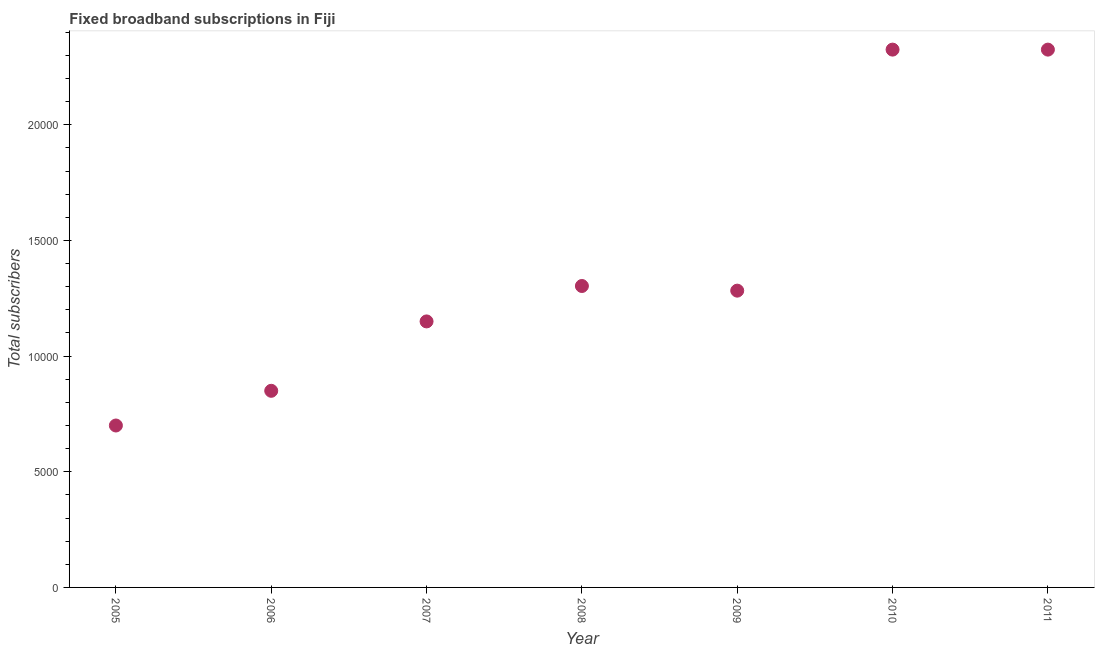What is the total number of fixed broadband subscriptions in 2009?
Provide a succinct answer. 1.28e+04. Across all years, what is the maximum total number of fixed broadband subscriptions?
Your answer should be compact. 2.32e+04. Across all years, what is the minimum total number of fixed broadband subscriptions?
Keep it short and to the point. 7000. What is the sum of the total number of fixed broadband subscriptions?
Your response must be concise. 9.94e+04. What is the difference between the total number of fixed broadband subscriptions in 2006 and 2010?
Provide a short and direct response. -1.48e+04. What is the average total number of fixed broadband subscriptions per year?
Your answer should be very brief. 1.42e+04. What is the median total number of fixed broadband subscriptions?
Offer a terse response. 1.28e+04. In how many years, is the total number of fixed broadband subscriptions greater than 6000 ?
Offer a terse response. 7. What is the ratio of the total number of fixed broadband subscriptions in 2006 to that in 2009?
Your answer should be compact. 0.66. Is the total number of fixed broadband subscriptions in 2007 less than that in 2010?
Give a very brief answer. Yes. Is the difference between the total number of fixed broadband subscriptions in 2009 and 2010 greater than the difference between any two years?
Your response must be concise. No. Is the sum of the total number of fixed broadband subscriptions in 2005 and 2006 greater than the maximum total number of fixed broadband subscriptions across all years?
Offer a very short reply. No. What is the difference between the highest and the lowest total number of fixed broadband subscriptions?
Ensure brevity in your answer.  1.62e+04. Does the total number of fixed broadband subscriptions monotonically increase over the years?
Provide a succinct answer. No. How many dotlines are there?
Ensure brevity in your answer.  1. How many years are there in the graph?
Your answer should be compact. 7. What is the difference between two consecutive major ticks on the Y-axis?
Your answer should be very brief. 5000. Are the values on the major ticks of Y-axis written in scientific E-notation?
Make the answer very short. No. Does the graph contain any zero values?
Ensure brevity in your answer.  No. Does the graph contain grids?
Offer a terse response. No. What is the title of the graph?
Give a very brief answer. Fixed broadband subscriptions in Fiji. What is the label or title of the X-axis?
Your answer should be very brief. Year. What is the label or title of the Y-axis?
Make the answer very short. Total subscribers. What is the Total subscribers in 2005?
Give a very brief answer. 7000. What is the Total subscribers in 2006?
Your answer should be compact. 8500. What is the Total subscribers in 2007?
Make the answer very short. 1.15e+04. What is the Total subscribers in 2008?
Provide a short and direct response. 1.30e+04. What is the Total subscribers in 2009?
Make the answer very short. 1.28e+04. What is the Total subscribers in 2010?
Your response must be concise. 2.32e+04. What is the Total subscribers in 2011?
Offer a terse response. 2.32e+04. What is the difference between the Total subscribers in 2005 and 2006?
Your answer should be compact. -1500. What is the difference between the Total subscribers in 2005 and 2007?
Make the answer very short. -4500. What is the difference between the Total subscribers in 2005 and 2008?
Give a very brief answer. -6031. What is the difference between the Total subscribers in 2005 and 2009?
Give a very brief answer. -5830. What is the difference between the Total subscribers in 2005 and 2010?
Give a very brief answer. -1.62e+04. What is the difference between the Total subscribers in 2005 and 2011?
Your response must be concise. -1.62e+04. What is the difference between the Total subscribers in 2006 and 2007?
Offer a terse response. -3000. What is the difference between the Total subscribers in 2006 and 2008?
Provide a short and direct response. -4531. What is the difference between the Total subscribers in 2006 and 2009?
Give a very brief answer. -4330. What is the difference between the Total subscribers in 2006 and 2010?
Make the answer very short. -1.48e+04. What is the difference between the Total subscribers in 2006 and 2011?
Give a very brief answer. -1.48e+04. What is the difference between the Total subscribers in 2007 and 2008?
Offer a very short reply. -1531. What is the difference between the Total subscribers in 2007 and 2009?
Keep it short and to the point. -1330. What is the difference between the Total subscribers in 2007 and 2010?
Your answer should be compact. -1.18e+04. What is the difference between the Total subscribers in 2007 and 2011?
Make the answer very short. -1.18e+04. What is the difference between the Total subscribers in 2008 and 2009?
Provide a short and direct response. 201. What is the difference between the Total subscribers in 2008 and 2010?
Your answer should be compact. -1.02e+04. What is the difference between the Total subscribers in 2008 and 2011?
Your answer should be compact. -1.02e+04. What is the difference between the Total subscribers in 2009 and 2010?
Offer a terse response. -1.04e+04. What is the difference between the Total subscribers in 2009 and 2011?
Your answer should be compact. -1.04e+04. What is the ratio of the Total subscribers in 2005 to that in 2006?
Offer a terse response. 0.82. What is the ratio of the Total subscribers in 2005 to that in 2007?
Ensure brevity in your answer.  0.61. What is the ratio of the Total subscribers in 2005 to that in 2008?
Provide a succinct answer. 0.54. What is the ratio of the Total subscribers in 2005 to that in 2009?
Your response must be concise. 0.55. What is the ratio of the Total subscribers in 2005 to that in 2010?
Ensure brevity in your answer.  0.3. What is the ratio of the Total subscribers in 2005 to that in 2011?
Offer a terse response. 0.3. What is the ratio of the Total subscribers in 2006 to that in 2007?
Your answer should be compact. 0.74. What is the ratio of the Total subscribers in 2006 to that in 2008?
Your answer should be compact. 0.65. What is the ratio of the Total subscribers in 2006 to that in 2009?
Make the answer very short. 0.66. What is the ratio of the Total subscribers in 2006 to that in 2010?
Make the answer very short. 0.37. What is the ratio of the Total subscribers in 2006 to that in 2011?
Provide a short and direct response. 0.37. What is the ratio of the Total subscribers in 2007 to that in 2008?
Ensure brevity in your answer.  0.88. What is the ratio of the Total subscribers in 2007 to that in 2009?
Give a very brief answer. 0.9. What is the ratio of the Total subscribers in 2007 to that in 2010?
Your answer should be compact. 0.49. What is the ratio of the Total subscribers in 2007 to that in 2011?
Offer a very short reply. 0.49. What is the ratio of the Total subscribers in 2008 to that in 2010?
Provide a short and direct response. 0.56. What is the ratio of the Total subscribers in 2008 to that in 2011?
Offer a terse response. 0.56. What is the ratio of the Total subscribers in 2009 to that in 2010?
Keep it short and to the point. 0.55. What is the ratio of the Total subscribers in 2009 to that in 2011?
Offer a terse response. 0.55. What is the ratio of the Total subscribers in 2010 to that in 2011?
Make the answer very short. 1. 